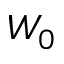<formula> <loc_0><loc_0><loc_500><loc_500>W _ { 0 }</formula> 